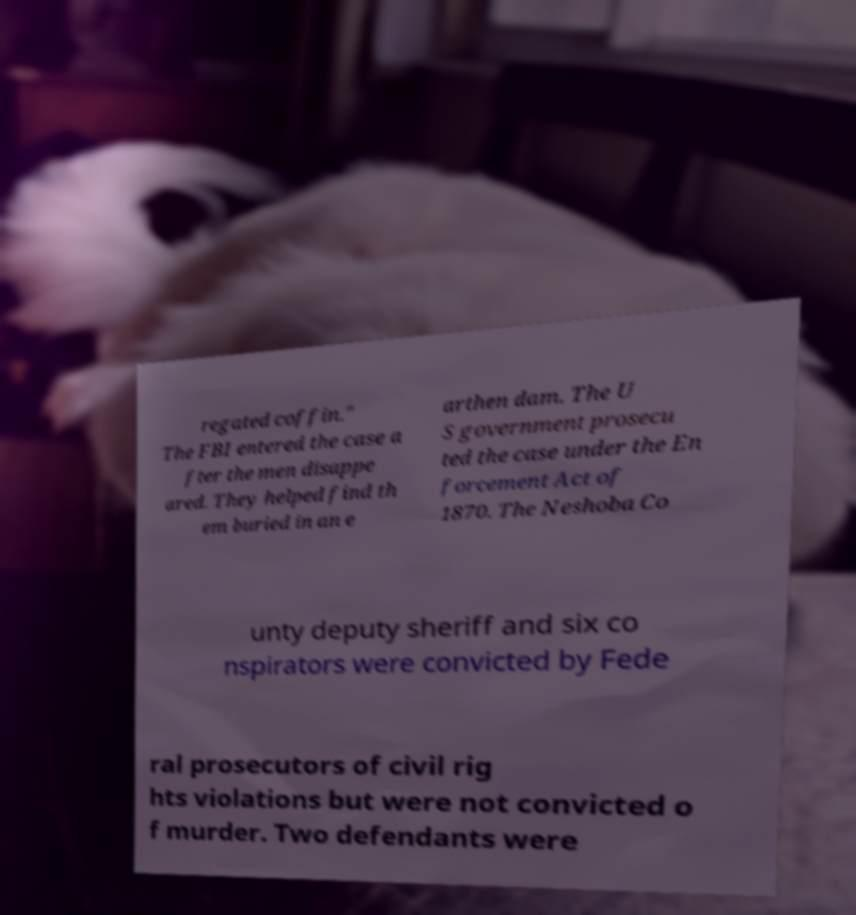There's text embedded in this image that I need extracted. Can you transcribe it verbatim? regated coffin." The FBI entered the case a fter the men disappe ared. They helped find th em buried in an e arthen dam. The U S government prosecu ted the case under the En forcement Act of 1870. The Neshoba Co unty deputy sheriff and six co nspirators were convicted by Fede ral prosecutors of civil rig hts violations but were not convicted o f murder. Two defendants were 